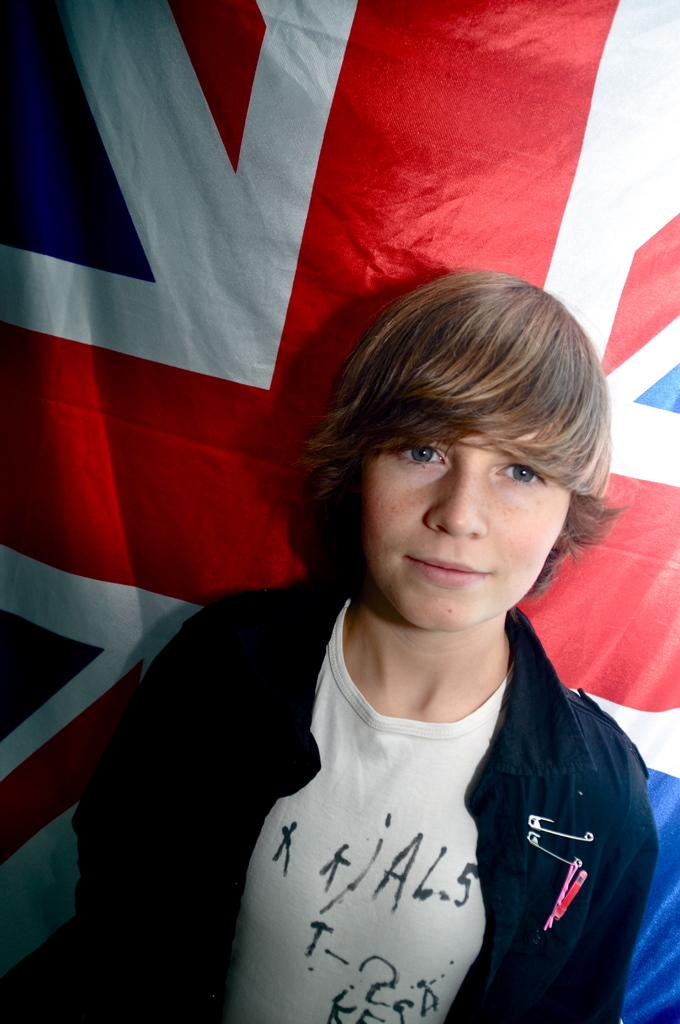Who is the main subject in the image? The main subject in the image is a boy. What is the boy standing in front of? The boy is standing in front of a flag. Who is the boy looking at? The boy is looking at someone. What type of island can be seen in the background of the image? There is no island present in the image. How does the boy change his appearance in the image? The boy does not change his appearance in the image. 